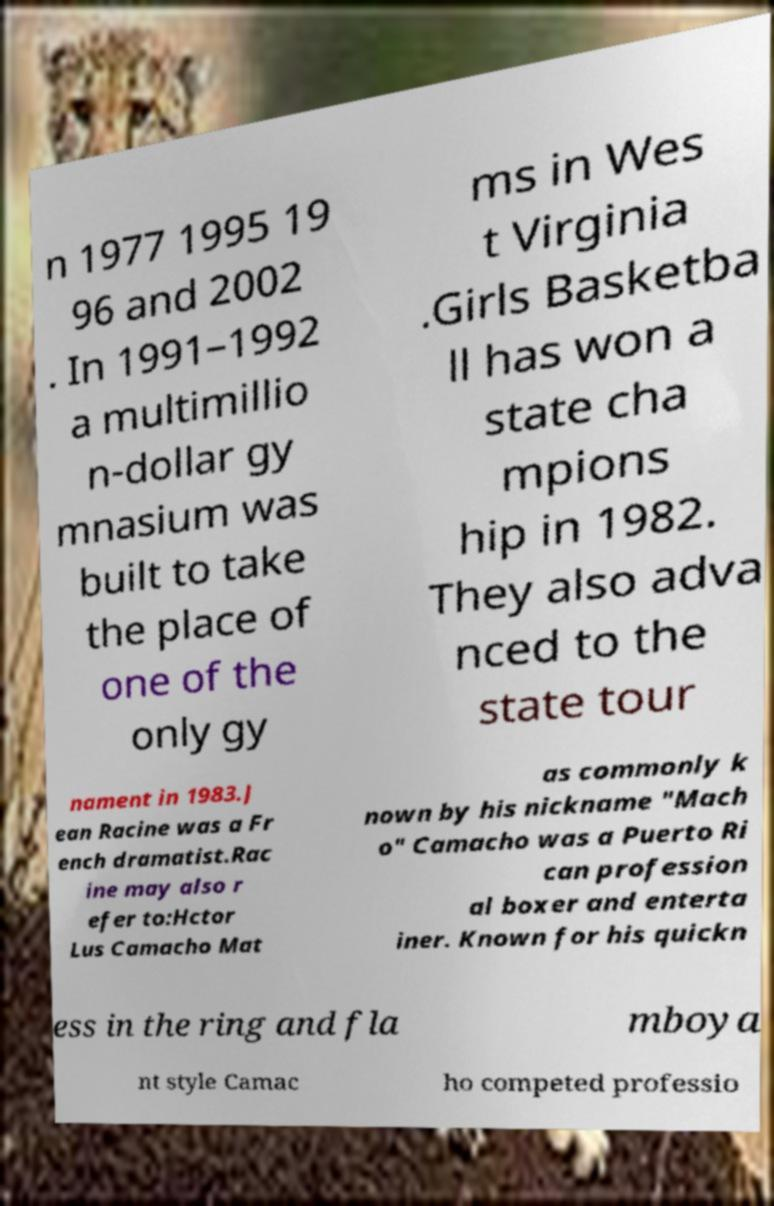I need the written content from this picture converted into text. Can you do that? n 1977 1995 19 96 and 2002 . In 1991–1992 a multimillio n-dollar gy mnasium was built to take the place of one of the only gy ms in Wes t Virginia .Girls Basketba ll has won a state cha mpions hip in 1982. They also adva nced to the state tour nament in 1983.J ean Racine was a Fr ench dramatist.Rac ine may also r efer to:Hctor Lus Camacho Mat as commonly k nown by his nickname "Mach o" Camacho was a Puerto Ri can profession al boxer and enterta iner. Known for his quickn ess in the ring and fla mboya nt style Camac ho competed professio 